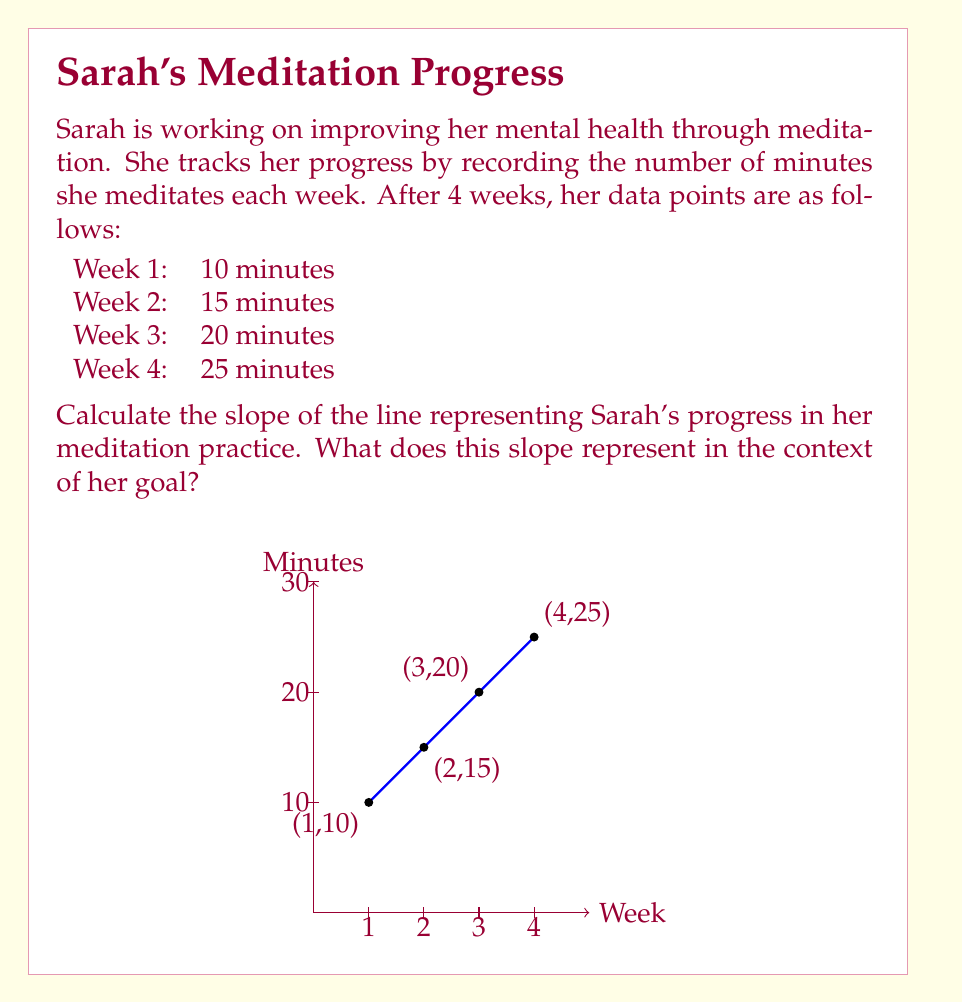Could you help me with this problem? To calculate the slope of the line representing Sarah's progress, we'll use the slope formula:

$$ \text{slope} = m = \frac{y_2 - y_1}{x_2 - x_1} $$

Where $(x_1, y_1)$ and $(x_2, y_2)$ are two points on the line.

Let's use the first and last data points:
$(x_1, y_1) = (1, 10)$ (Week 1, 10 minutes)
$(x_2, y_2) = (4, 25)$ (Week 4, 25 minutes)

Plugging these into the slope formula:

$$ m = \frac{25 - 10}{4 - 1} = \frac{15}{3} = 5 $$

The slope of the line is 5.

In the context of Sarah's meditation goal, this slope represents the rate at which she is increasing her meditation time. Specifically, it means she is increasing her meditation time by 5 minutes per week on average.

This positive slope indicates that Sarah is making consistent progress towards her goal of improving her mental health through meditation.
Answer: 5 minutes/week 